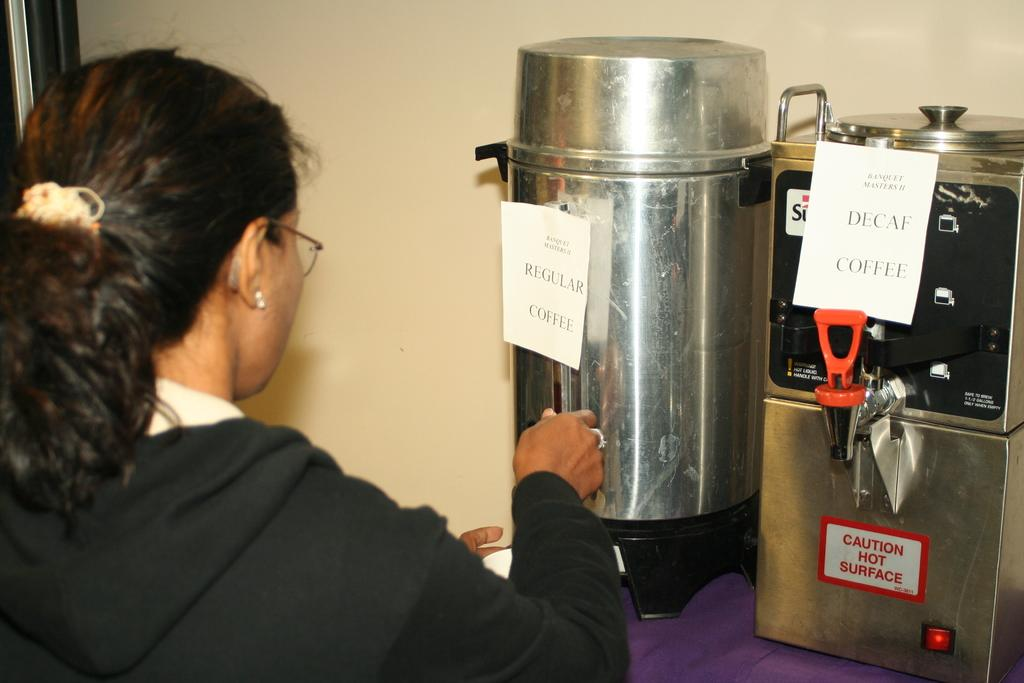<image>
Offer a succinct explanation of the picture presented. A women using a coffee dispenser labeled "Regular Coffee". 